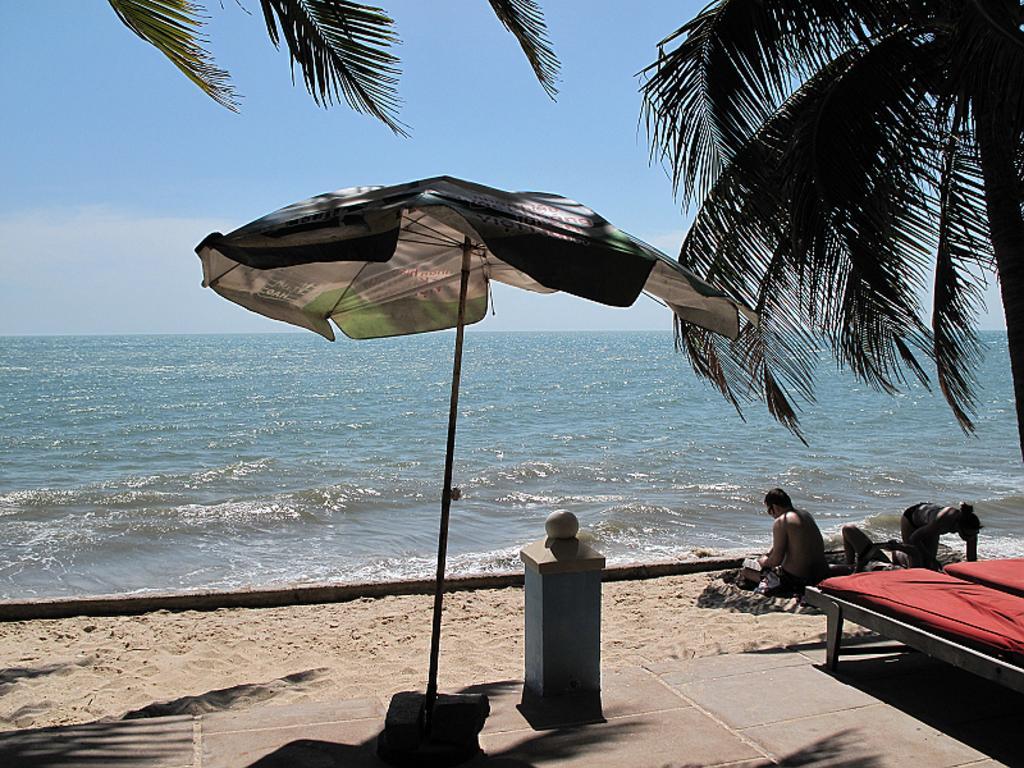How would you summarize this image in a sentence or two? In this picture I can see there are few people lying on the sand and there are trees, sand and in the backdrop I can see there is a ocean and the sky is clear. 